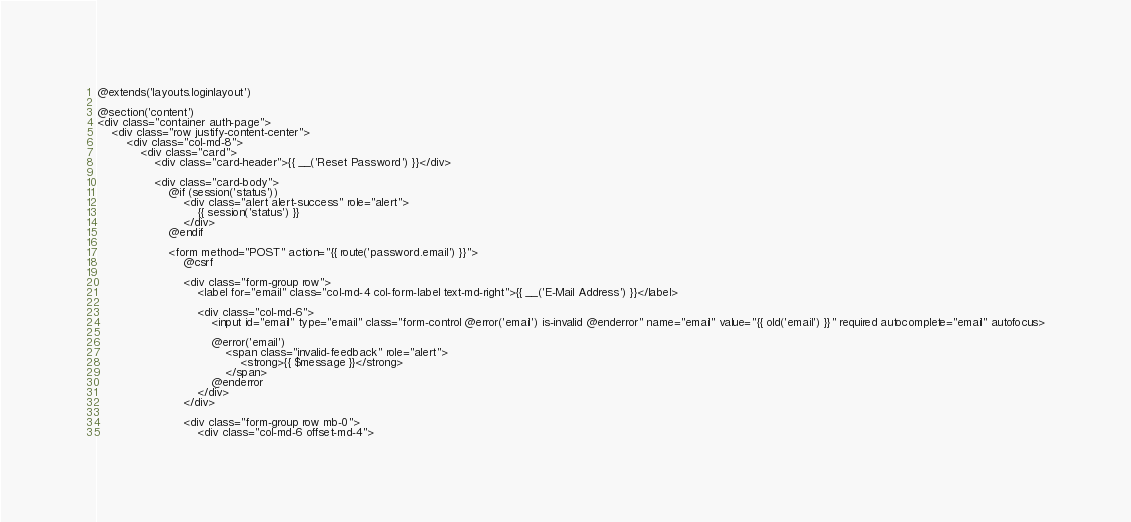Convert code to text. <code><loc_0><loc_0><loc_500><loc_500><_PHP_>@extends('layouts.loginlayout')

@section('content')
<div class="container auth-page">
    <div class="row justify-content-center">
        <div class="col-md-8">
            <div class="card">
                <div class="card-header">{{ __('Reset Password') }}</div>

                <div class="card-body">
                    @if (session('status'))
                        <div class="alert alert-success" role="alert">
                            {{ session('status') }}
                        </div>
                    @endif

                    <form method="POST" action="{{ route('password.email') }}">
                        @csrf

                        <div class="form-group row">
                            <label for="email" class="col-md-4 col-form-label text-md-right">{{ __('E-Mail Address') }}</label>

                            <div class="col-md-6">
                                <input id="email" type="email" class="form-control @error('email') is-invalid @enderror" name="email" value="{{ old('email') }}" required autocomplete="email" autofocus>

                                @error('email')
                                    <span class="invalid-feedback" role="alert">
                                        <strong>{{ $message }}</strong>
                                    </span>
                                @enderror
                            </div>
                        </div>

                        <div class="form-group row mb-0">
                            <div class="col-md-6 offset-md-4"></code> 